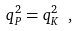Convert formula to latex. <formula><loc_0><loc_0><loc_500><loc_500>q _ { P } ^ { 2 } = q _ { K } ^ { 2 } \ ,</formula> 